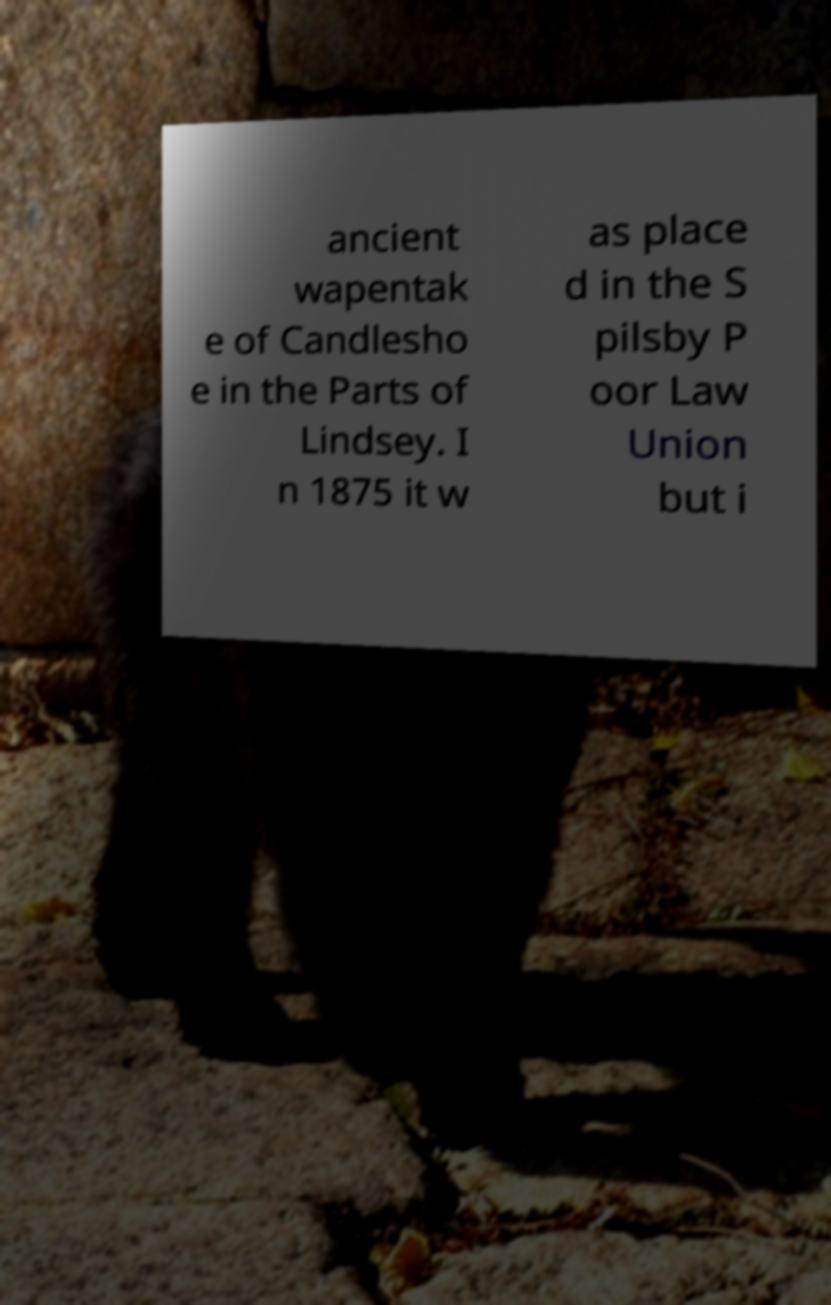I need the written content from this picture converted into text. Can you do that? ancient wapentak e of Candlesho e in the Parts of Lindsey. I n 1875 it w as place d in the S pilsby P oor Law Union but i 